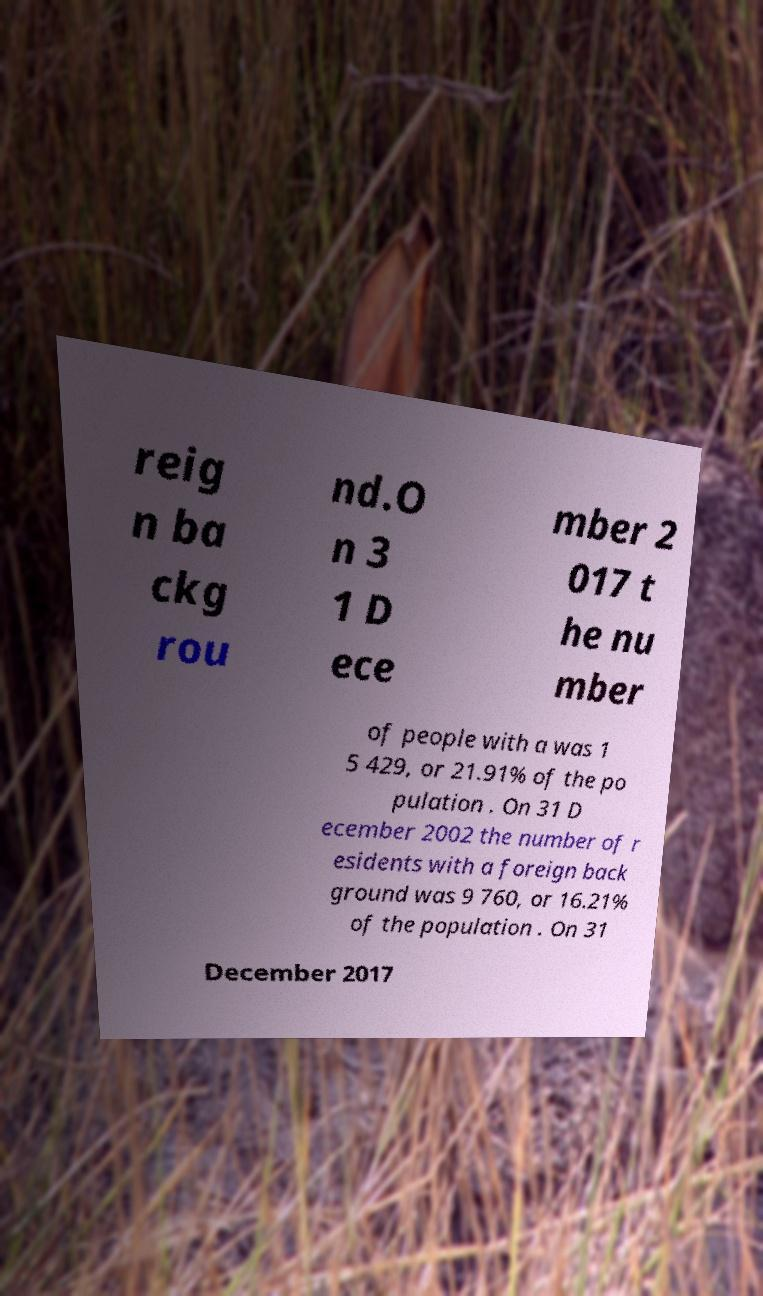What messages or text are displayed in this image? I need them in a readable, typed format. reig n ba ckg rou nd.O n 3 1 D ece mber 2 017 t he nu mber of people with a was 1 5 429, or 21.91% of the po pulation . On 31 D ecember 2002 the number of r esidents with a foreign back ground was 9 760, or 16.21% of the population . On 31 December 2017 